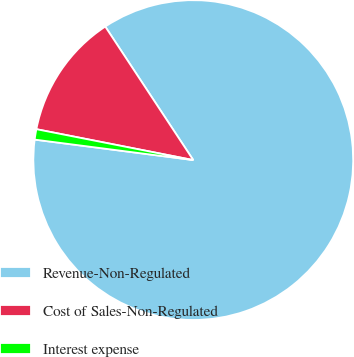<chart> <loc_0><loc_0><loc_500><loc_500><pie_chart><fcel>Revenue-Non-Regulated<fcel>Cost of Sales-Non-Regulated<fcel>Interest expense<nl><fcel>86.32%<fcel>12.63%<fcel>1.05%<nl></chart> 